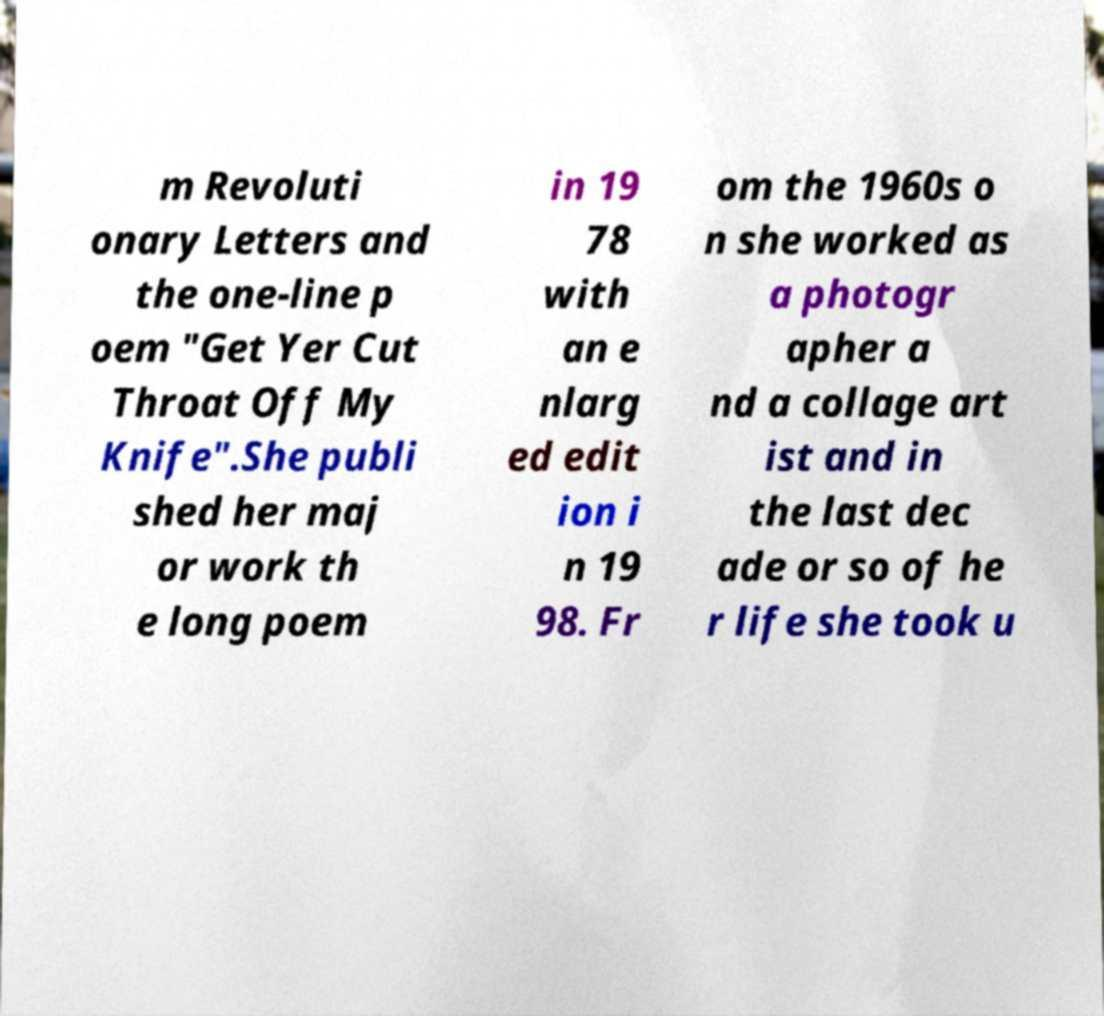Can you accurately transcribe the text from the provided image for me? m Revoluti onary Letters and the one-line p oem "Get Yer Cut Throat Off My Knife".She publi shed her maj or work th e long poem in 19 78 with an e nlarg ed edit ion i n 19 98. Fr om the 1960s o n she worked as a photogr apher a nd a collage art ist and in the last dec ade or so of he r life she took u 